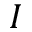Convert formula to latex. <formula><loc_0><loc_0><loc_500><loc_500>I</formula> 